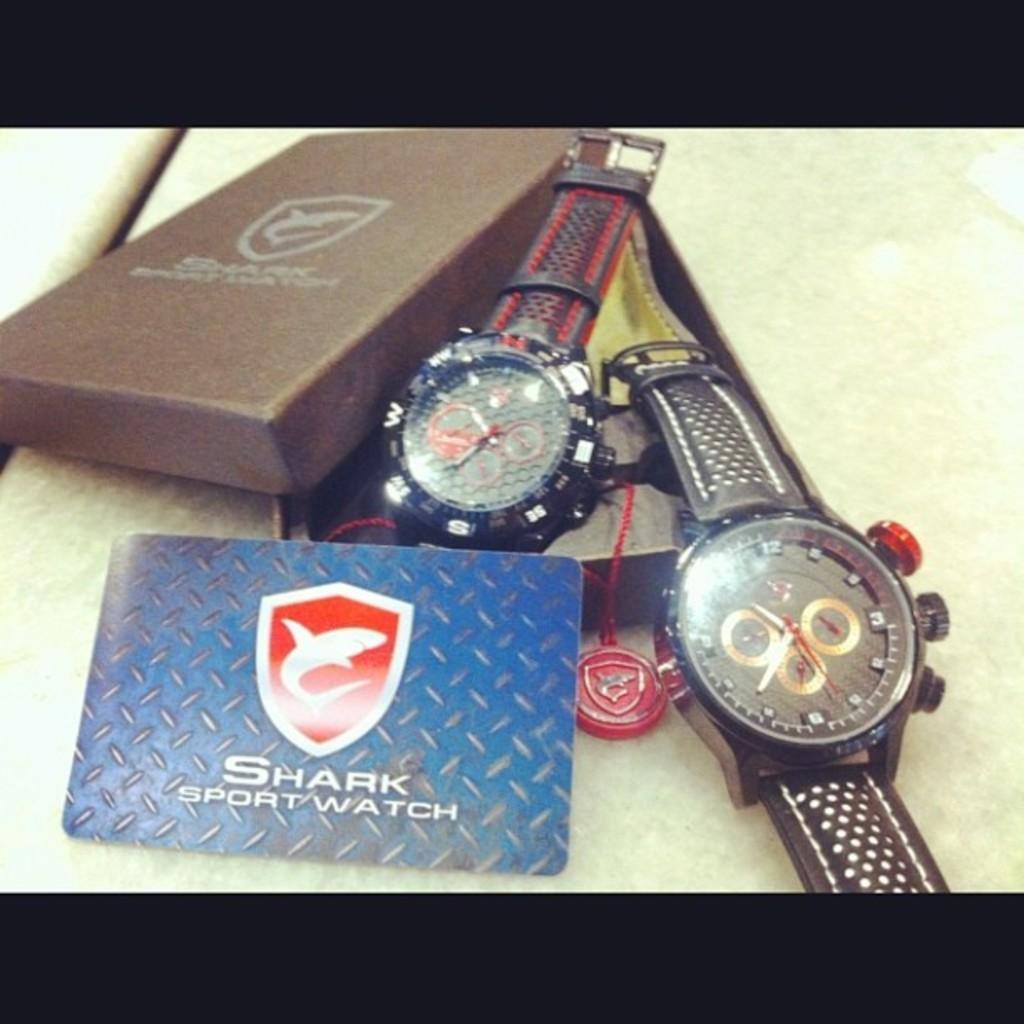<image>
Render a clear and concise summary of the photo. Two watches one in a box and one half out sitting beside a card that says Shark Sports Watch. 